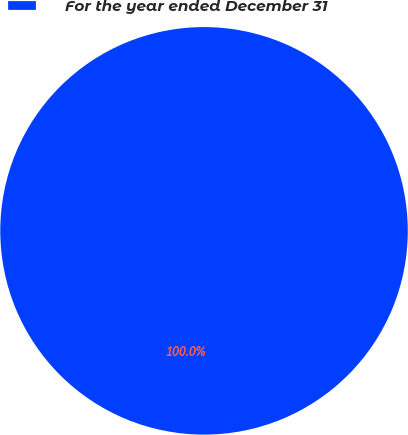Convert chart to OTSL. <chart><loc_0><loc_0><loc_500><loc_500><pie_chart><fcel>For the year ended December 31<nl><fcel>100.0%<nl></chart> 